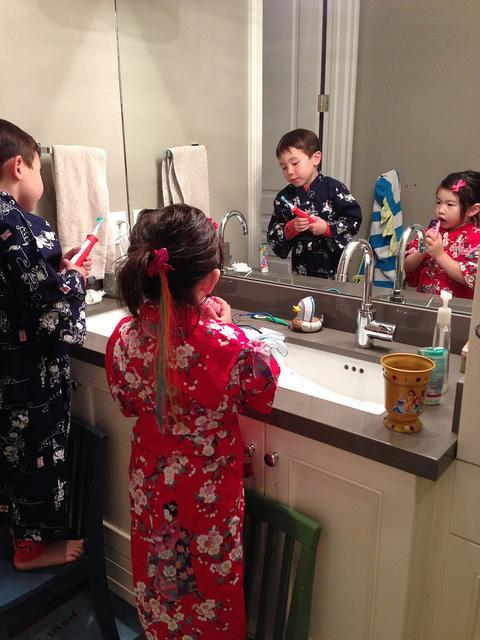What protects the sink from overflowing?
Quick response, please. Drain. What type of toothbrush does the boy have in hands?
Quick response, please. Electric. What are the kids doing?
Keep it brief. Brushing teeth. 